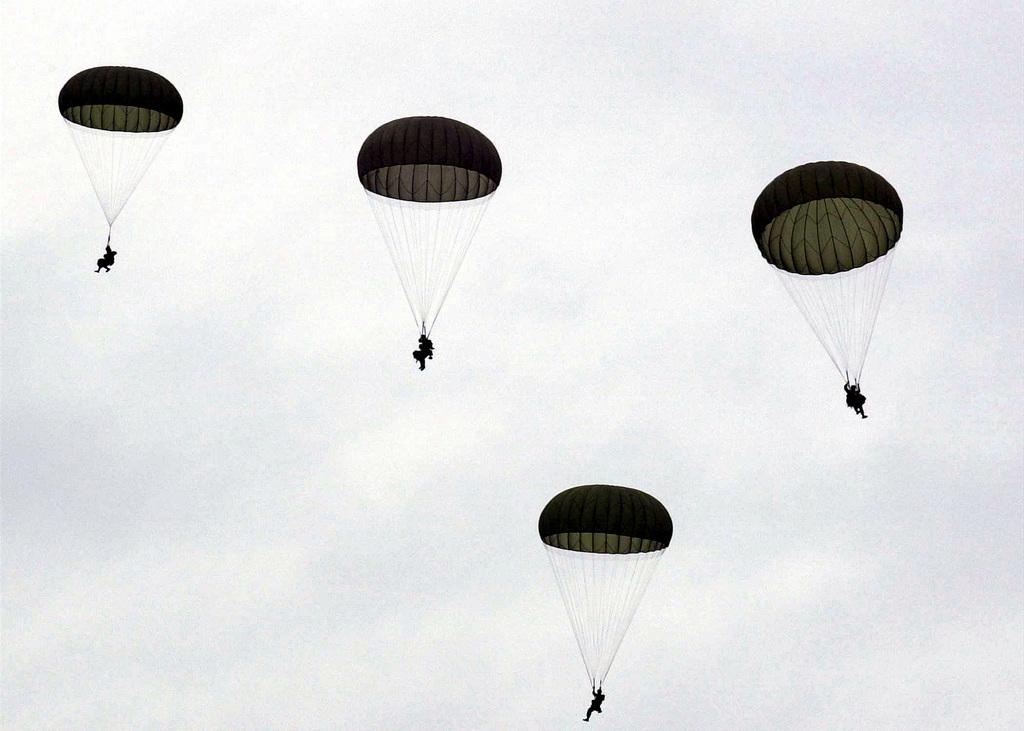How many people are in the image? There are persons in the image. What are the persons doing in the image? The persons are flying in the sky. How are the persons able to fly in the sky? The persons are using parachutes. What type of bird can be seen flying alongside the persons in the image? There are no birds visible in the image; the persons are flying using parachutes. 